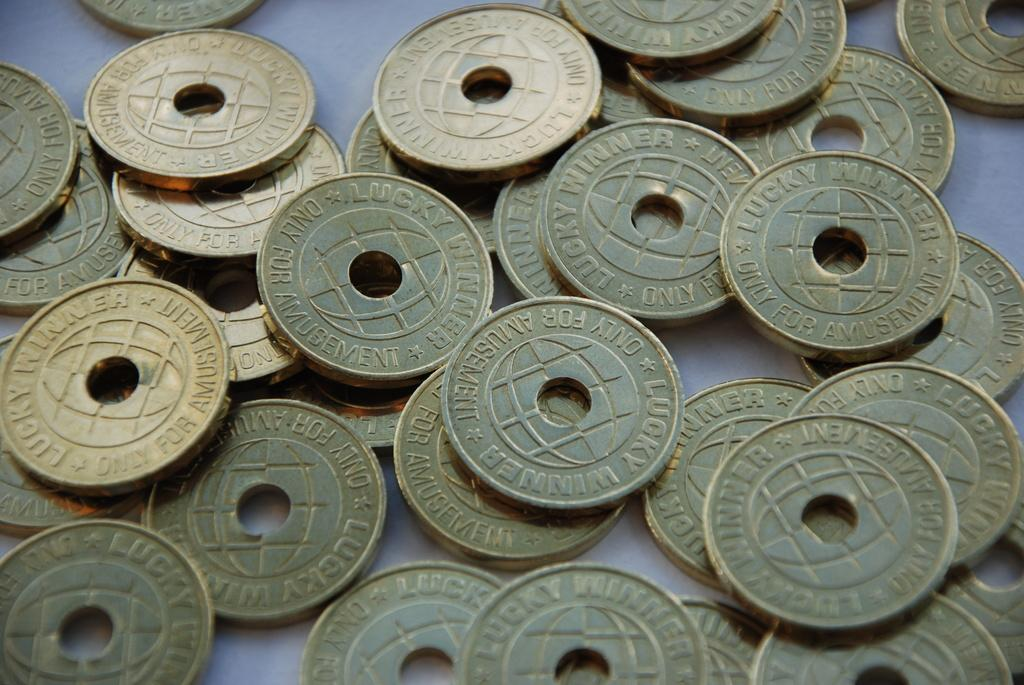Provide a one-sentence caption for the provided image. Multiple gold plated lucky winner amusement coins laying on a table. 